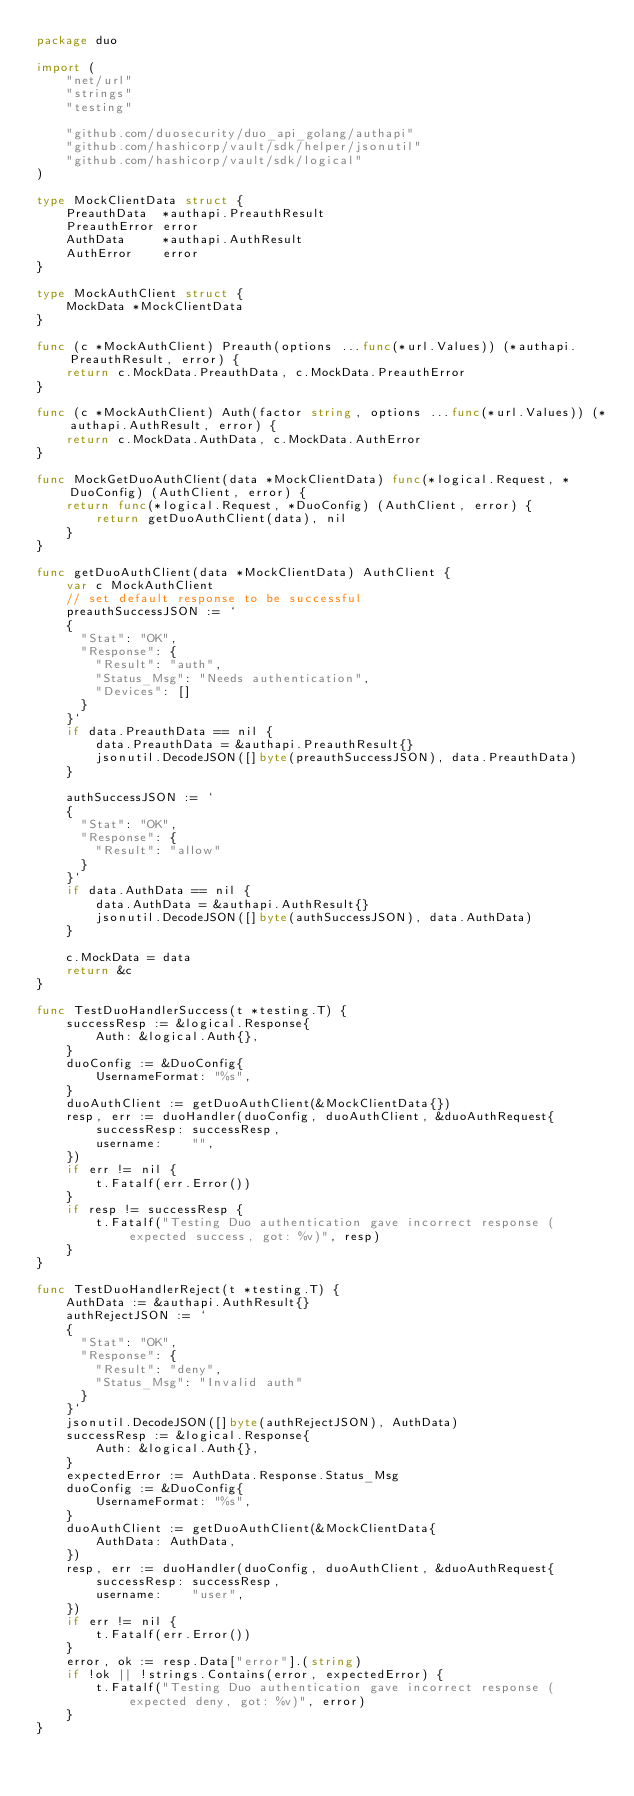Convert code to text. <code><loc_0><loc_0><loc_500><loc_500><_Go_>package duo

import (
	"net/url"
	"strings"
	"testing"

	"github.com/duosecurity/duo_api_golang/authapi"
	"github.com/hashicorp/vault/sdk/helper/jsonutil"
	"github.com/hashicorp/vault/sdk/logical"
)

type MockClientData struct {
	PreauthData  *authapi.PreauthResult
	PreauthError error
	AuthData     *authapi.AuthResult
	AuthError    error
}

type MockAuthClient struct {
	MockData *MockClientData
}

func (c *MockAuthClient) Preauth(options ...func(*url.Values)) (*authapi.PreauthResult, error) {
	return c.MockData.PreauthData, c.MockData.PreauthError
}

func (c *MockAuthClient) Auth(factor string, options ...func(*url.Values)) (*authapi.AuthResult, error) {
	return c.MockData.AuthData, c.MockData.AuthError
}

func MockGetDuoAuthClient(data *MockClientData) func(*logical.Request, *DuoConfig) (AuthClient, error) {
	return func(*logical.Request, *DuoConfig) (AuthClient, error) {
		return getDuoAuthClient(data), nil
	}
}

func getDuoAuthClient(data *MockClientData) AuthClient {
	var c MockAuthClient
	// set default response to be successful
	preauthSuccessJSON := `
	{
	  "Stat": "OK",
	  "Response": {
	    "Result": "auth",
	    "Status_Msg": "Needs authentication",
	    "Devices": []
	  }
	}`
	if data.PreauthData == nil {
		data.PreauthData = &authapi.PreauthResult{}
		jsonutil.DecodeJSON([]byte(preauthSuccessJSON), data.PreauthData)
	}

	authSuccessJSON := `
	{
	  "Stat": "OK",
	  "Response": {
	    "Result": "allow"
	  }
	}`
	if data.AuthData == nil {
		data.AuthData = &authapi.AuthResult{}
		jsonutil.DecodeJSON([]byte(authSuccessJSON), data.AuthData)
	}

	c.MockData = data
	return &c
}

func TestDuoHandlerSuccess(t *testing.T) {
	successResp := &logical.Response{
		Auth: &logical.Auth{},
	}
	duoConfig := &DuoConfig{
		UsernameFormat: "%s",
	}
	duoAuthClient := getDuoAuthClient(&MockClientData{})
	resp, err := duoHandler(duoConfig, duoAuthClient, &duoAuthRequest{
		successResp: successResp,
		username:    "",
	})
	if err != nil {
		t.Fatalf(err.Error())
	}
	if resp != successResp {
		t.Fatalf("Testing Duo authentication gave incorrect response (expected success, got: %v)", resp)
	}
}

func TestDuoHandlerReject(t *testing.T) {
	AuthData := &authapi.AuthResult{}
	authRejectJSON := `
	{
	  "Stat": "OK",
	  "Response": {
	    "Result": "deny",
	    "Status_Msg": "Invalid auth"
	  }
	}`
	jsonutil.DecodeJSON([]byte(authRejectJSON), AuthData)
	successResp := &logical.Response{
		Auth: &logical.Auth{},
	}
	expectedError := AuthData.Response.Status_Msg
	duoConfig := &DuoConfig{
		UsernameFormat: "%s",
	}
	duoAuthClient := getDuoAuthClient(&MockClientData{
		AuthData: AuthData,
	})
	resp, err := duoHandler(duoConfig, duoAuthClient, &duoAuthRequest{
		successResp: successResp,
		username:    "user",
	})
	if err != nil {
		t.Fatalf(err.Error())
	}
	error, ok := resp.Data["error"].(string)
	if !ok || !strings.Contains(error, expectedError) {
		t.Fatalf("Testing Duo authentication gave incorrect response (expected deny, got: %v)", error)
	}
}
</code> 